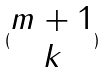Convert formula to latex. <formula><loc_0><loc_0><loc_500><loc_500>( \begin{matrix} m + 1 \\ k \end{matrix} )</formula> 